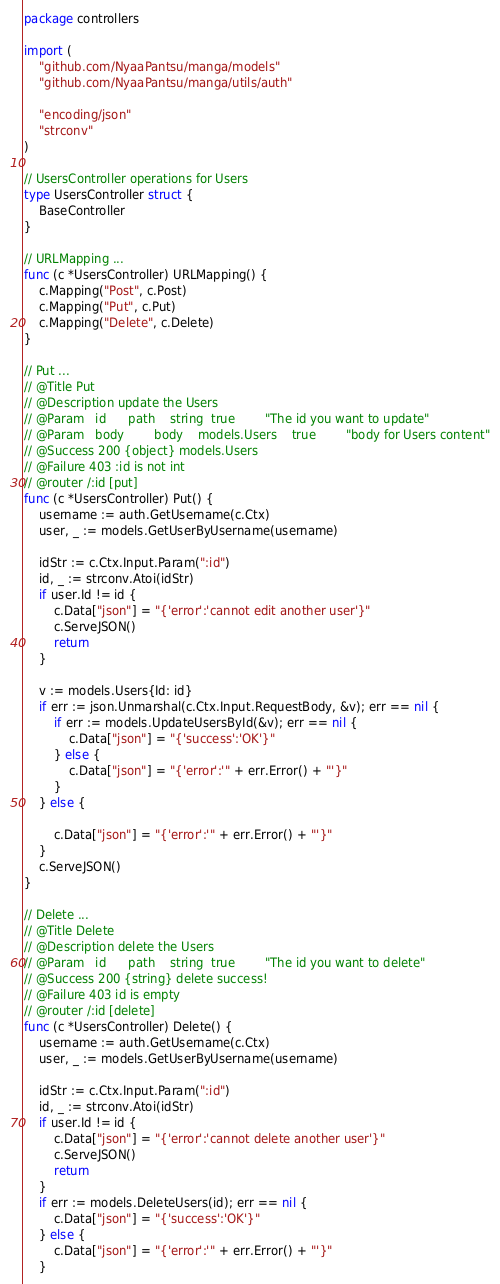Convert code to text. <code><loc_0><loc_0><loc_500><loc_500><_Go_>package controllers

import (
	"github.com/NyaaPantsu/manga/models"
	"github.com/NyaaPantsu/manga/utils/auth"

	"encoding/json"
	"strconv"
)

// UsersController operations for Users
type UsersController struct {
	BaseController
}

// URLMapping ...
func (c *UsersController) URLMapping() {
	c.Mapping("Post", c.Post)
	c.Mapping("Put", c.Put)
	c.Mapping("Delete", c.Delete)
}

// Put ...
// @Title Put
// @Description update the Users
// @Param	id		path 	string	true		"The id you want to update"
// @Param	body		body 	models.Users	true		"body for Users content"
// @Success 200 {object} models.Users
// @Failure 403 :id is not int
// @router /:id [put]
func (c *UsersController) Put() {
	username := auth.GetUsername(c.Ctx)
	user, _ := models.GetUserByUsername(username)

	idStr := c.Ctx.Input.Param(":id")
	id, _ := strconv.Atoi(idStr)
	if user.Id != id {
		c.Data["json"] = "{'error':'cannot edit another user'}"
		c.ServeJSON()
		return
	}

	v := models.Users{Id: id}
	if err := json.Unmarshal(c.Ctx.Input.RequestBody, &v); err == nil {
		if err := models.UpdateUsersById(&v); err == nil {
			c.Data["json"] = "{'success':'OK'}"
		} else {
			c.Data["json"] = "{'error':'" + err.Error() + "'}"
		}
	} else {

		c.Data["json"] = "{'error':'" + err.Error() + "'}"
	}
	c.ServeJSON()
}

// Delete ...
// @Title Delete
// @Description delete the Users
// @Param	id		path 	string	true		"The id you want to delete"
// @Success 200 {string} delete success!
// @Failure 403 id is empty
// @router /:id [delete]
func (c *UsersController) Delete() {
	username := auth.GetUsername(c.Ctx)
	user, _ := models.GetUserByUsername(username)

	idStr := c.Ctx.Input.Param(":id")
	id, _ := strconv.Atoi(idStr)
	if user.Id != id {
		c.Data["json"] = "{'error':'cannot delete another user'}"
		c.ServeJSON()
		return
	}
	if err := models.DeleteUsers(id); err == nil {
		c.Data["json"] = "{'success':'OK'}"
	} else {
		c.Data["json"] = "{'error':'" + err.Error() + "'}"
	}</code> 